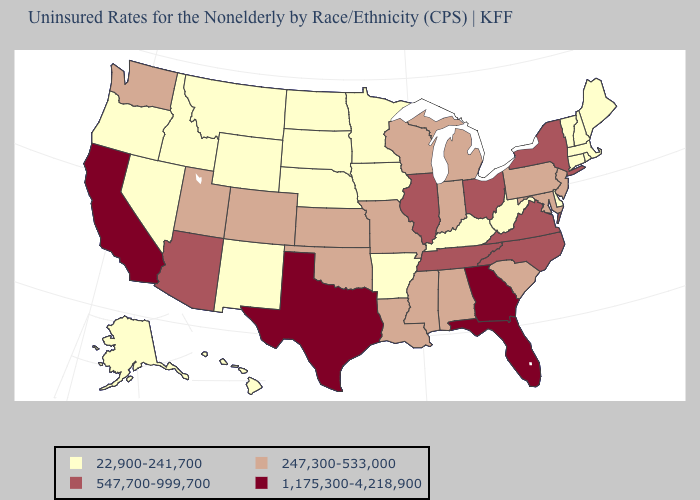What is the highest value in the MidWest ?
Quick response, please. 547,700-999,700. Among the states that border Vermont , does New York have the highest value?
Quick response, please. Yes. Name the states that have a value in the range 547,700-999,700?
Short answer required. Arizona, Illinois, New York, North Carolina, Ohio, Tennessee, Virginia. Does Minnesota have the highest value in the USA?
Short answer required. No. What is the lowest value in the West?
Write a very short answer. 22,900-241,700. Does Tennessee have a lower value than Iowa?
Give a very brief answer. No. What is the lowest value in states that border South Dakota?
Quick response, please. 22,900-241,700. Does Tennessee have a lower value than Oregon?
Be succinct. No. Does Minnesota have the same value as South Dakota?
Give a very brief answer. Yes. What is the value of Delaware?
Give a very brief answer. 22,900-241,700. Name the states that have a value in the range 22,900-241,700?
Quick response, please. Alaska, Arkansas, Connecticut, Delaware, Hawaii, Idaho, Iowa, Kentucky, Maine, Massachusetts, Minnesota, Montana, Nebraska, Nevada, New Hampshire, New Mexico, North Dakota, Oregon, Rhode Island, South Dakota, Vermont, West Virginia, Wyoming. What is the value of Louisiana?
Quick response, please. 247,300-533,000. What is the lowest value in states that border Illinois?
Write a very short answer. 22,900-241,700. 